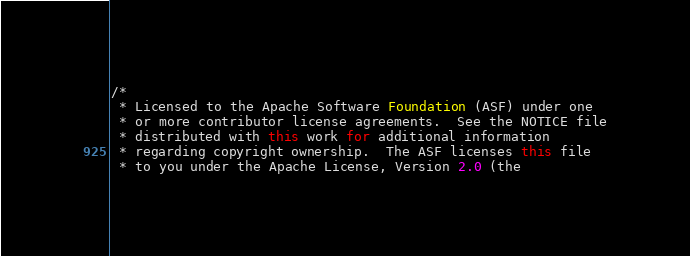Convert code to text. <code><loc_0><loc_0><loc_500><loc_500><_Java_>/*
 * Licensed to the Apache Software Foundation (ASF) under one
 * or more contributor license agreements.  See the NOTICE file
 * distributed with this work for additional information
 * regarding copyright ownership.  The ASF licenses this file
 * to you under the Apache License, Version 2.0 (the</code> 